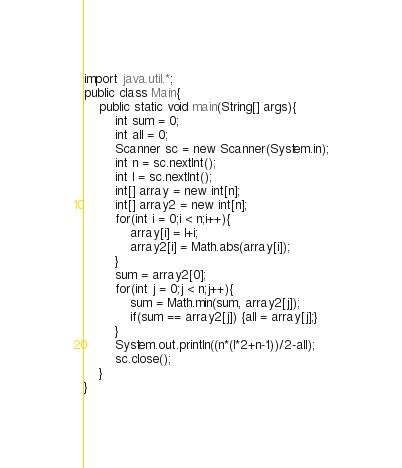<code> <loc_0><loc_0><loc_500><loc_500><_Java_>import java.util.*;
public class Main{
	public static void main(String[] args){
		int sum = 0;
		int all = 0;
    	Scanner sc = new Scanner(System.in);
      	int n = sc.nextInt();
      	int l = sc.nextInt();
      	int[] array = new int[n];
      	int[] array2 = new int[n];
      	for(int i = 0;i < n;i++){
      		array[i] = l+i;
          	array2[i] = Math.abs(array[i]);
      	}
      	sum = array2[0];
      	for(int j = 0;j < n;j++){
      		sum = Math.min(sum, array2[j]);
      		if(sum == array2[j]) {all = array[j];}
        }
      	System.out.println((n*(l*2+n-1))/2-all);
      	sc.close();
    }
}</code> 